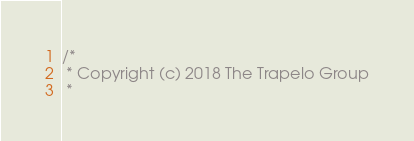<code> <loc_0><loc_0><loc_500><loc_500><_Scala_>/*
 * Copyright (c) 2018 The Trapelo Group
 *</code> 